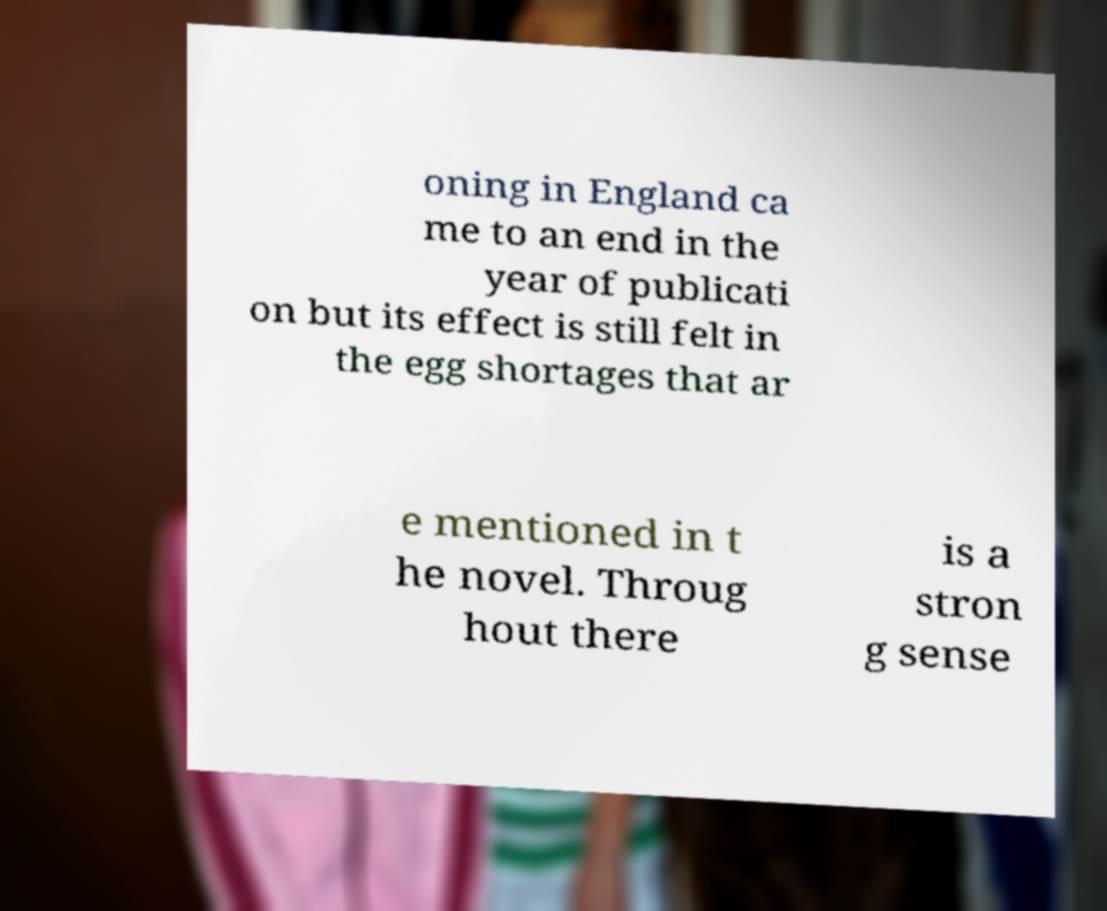There's text embedded in this image that I need extracted. Can you transcribe it verbatim? oning in England ca me to an end in the year of publicati on but its effect is still felt in the egg shortages that ar e mentioned in t he novel. Throug hout there is a stron g sense 